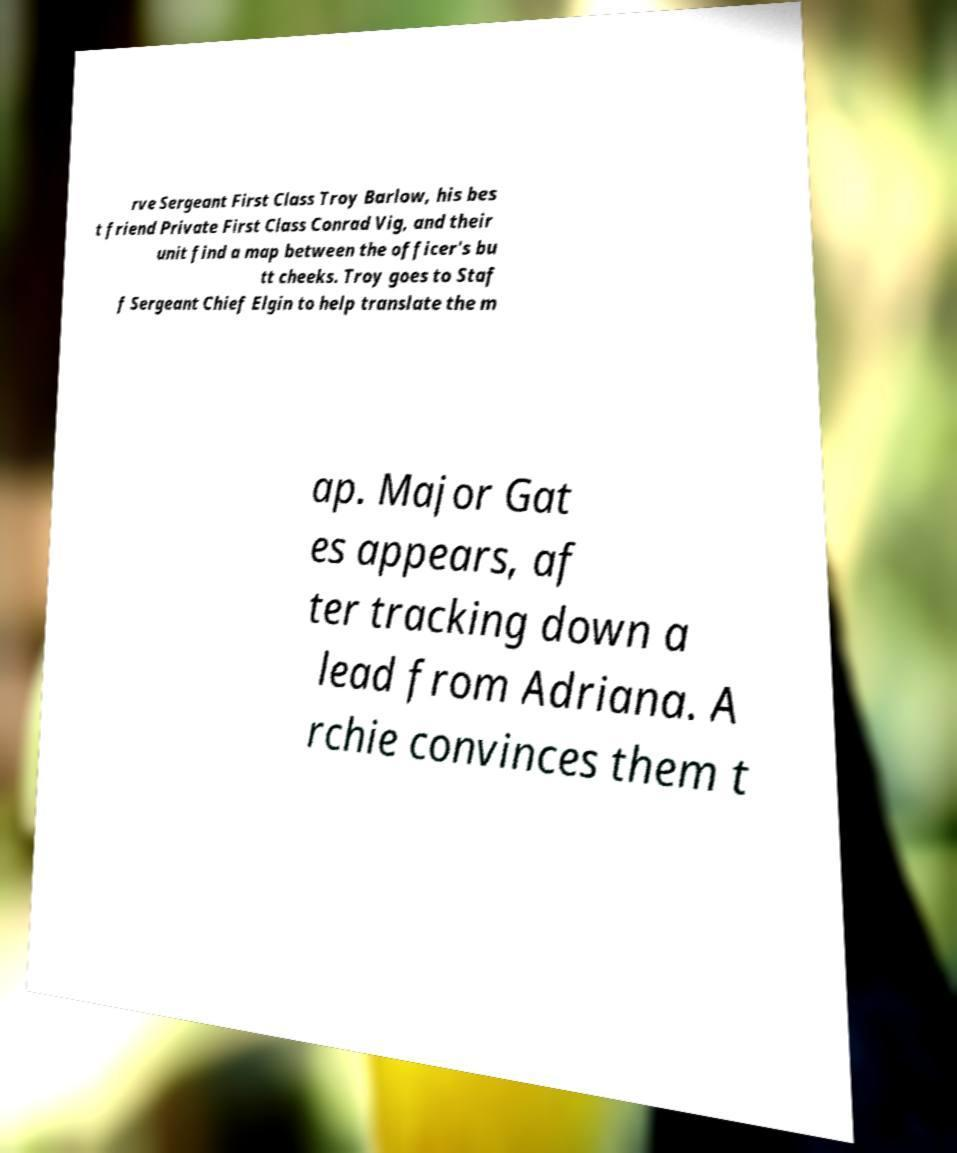For documentation purposes, I need the text within this image transcribed. Could you provide that? rve Sergeant First Class Troy Barlow, his bes t friend Private First Class Conrad Vig, and their unit find a map between the officer's bu tt cheeks. Troy goes to Staf f Sergeant Chief Elgin to help translate the m ap. Major Gat es appears, af ter tracking down a lead from Adriana. A rchie convinces them t 